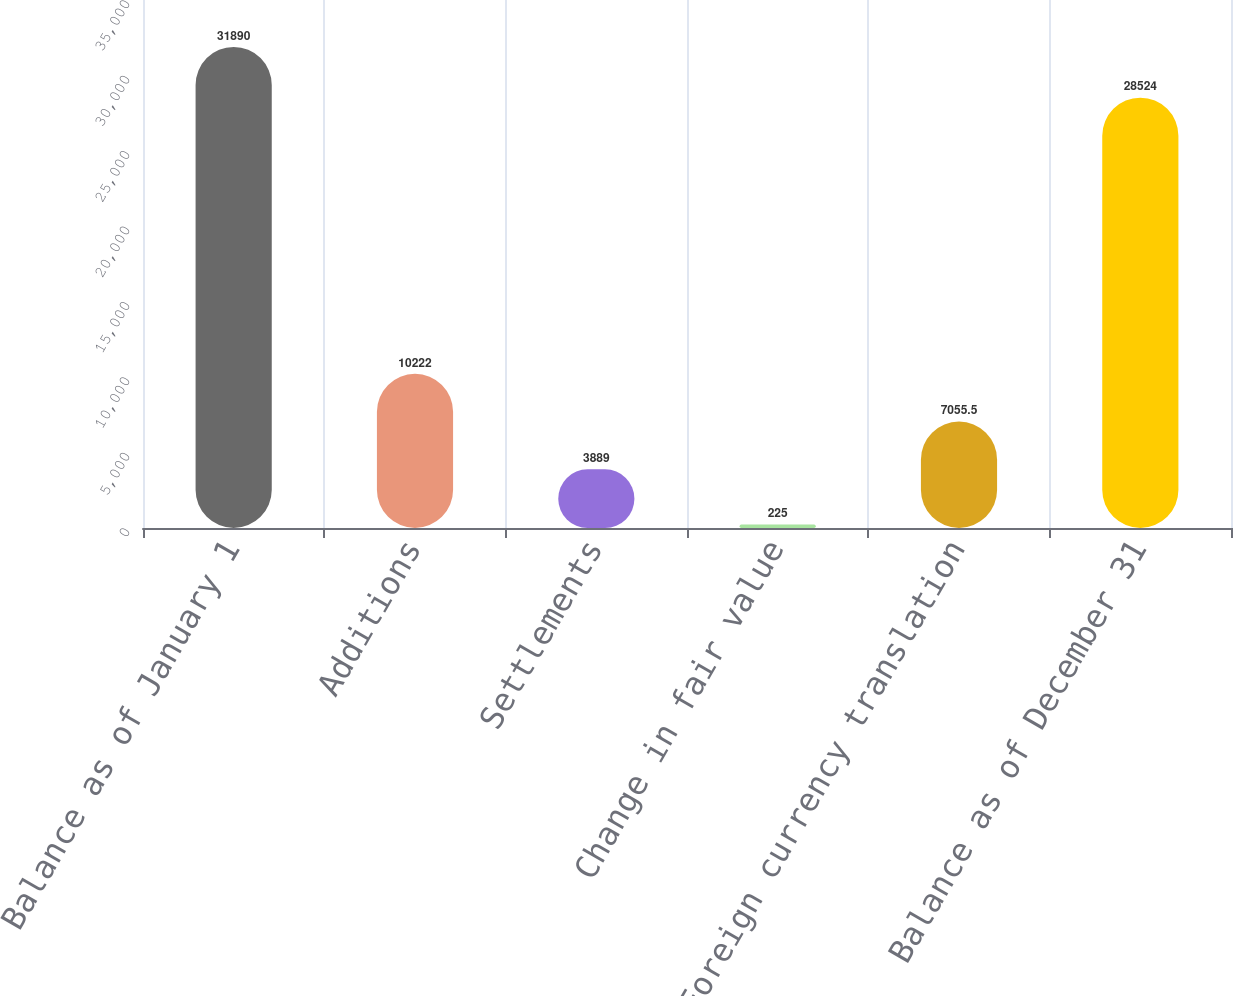<chart> <loc_0><loc_0><loc_500><loc_500><bar_chart><fcel>Balance as of January 1<fcel>Additions<fcel>Settlements<fcel>Change in fair value<fcel>Foreign currency translation<fcel>Balance as of December 31<nl><fcel>31890<fcel>10222<fcel>3889<fcel>225<fcel>7055.5<fcel>28524<nl></chart> 